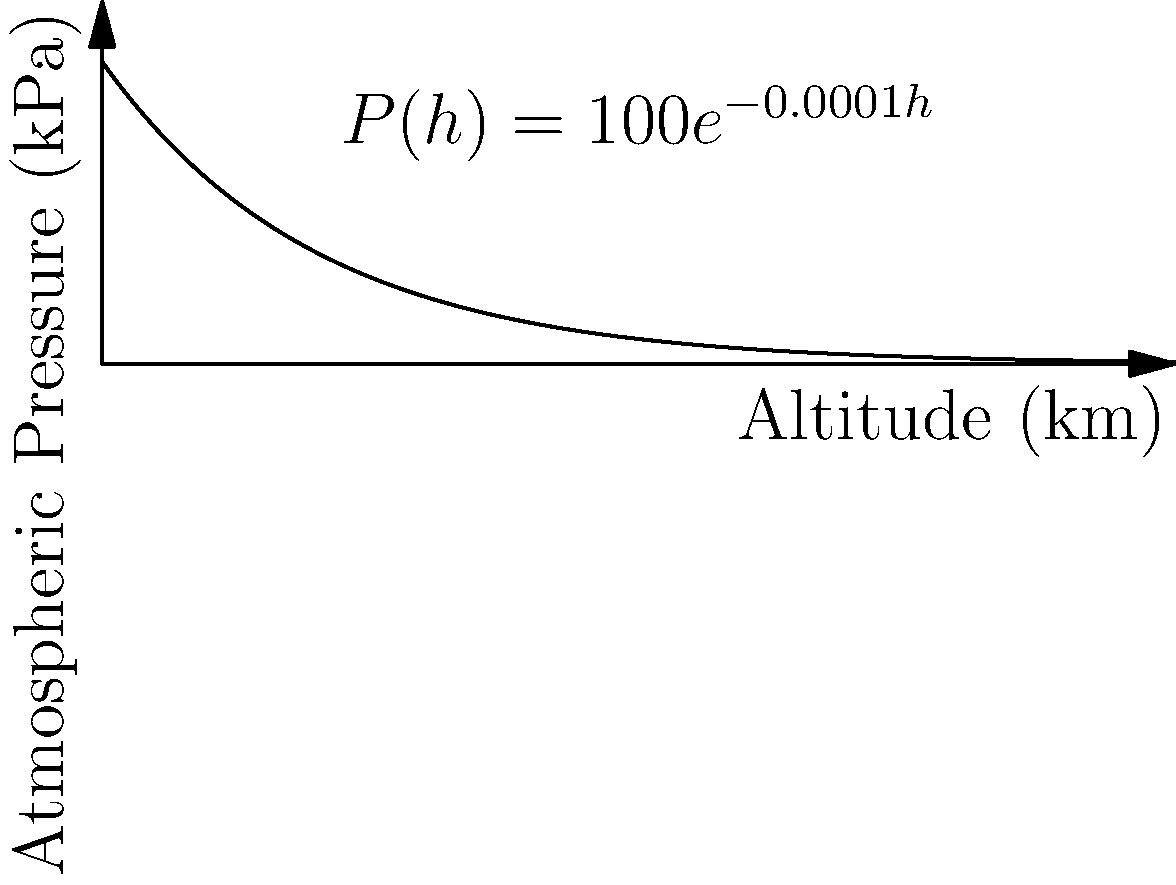The atmospheric pressure $P$ (in kPa) on an exoplanet varies with altitude $h$ (in km) according to the function $P(h) = 100e^{-0.0001h}$. At what altitude is the rate of change of atmospheric pressure with respect to altitude equal to $-0.005$ kPa/km? To solve this problem, we need to follow these steps:

1) The rate of change of atmospheric pressure with respect to altitude is given by the derivative of $P(h)$:

   $\frac{dP}{dh} = \frac{d}{dh}(100e^{-0.0001h}) = 100 \cdot (-0.0001) \cdot e^{-0.0001h} = -0.01e^{-0.0001h}$

2) We want to find the altitude where this rate equals $-0.005$ kPa/km:

   $-0.01e^{-0.0001h} = -0.005$

3) Dividing both sides by $-0.01$:

   $e^{-0.0001h} = 0.5$

4) Taking the natural logarithm of both sides:

   $-0.0001h = \ln(0.5)$

5) Solving for $h$:

   $h = \frac{\ln(0.5)}{-0.0001} = \frac{-0.69315}{-0.0001} \approx 6931.5$ km

Therefore, the rate of change of atmospheric pressure is $-0.005$ kPa/km at an altitude of approximately 6931.5 km.
Answer: 6931.5 km 